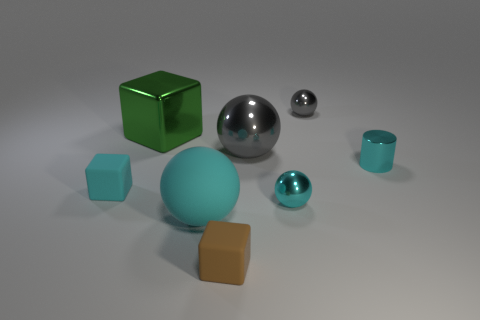What is the color of the tiny cylinder?
Provide a succinct answer. Cyan. There is a small shiny ball that is behind the cyan block; is there a thing in front of it?
Your answer should be compact. Yes. Is the number of small gray shiny objects that are in front of the big gray shiny ball less than the number of green metal cubes?
Provide a short and direct response. Yes. Are the tiny block that is to the right of the green object and the big green object made of the same material?
Your answer should be compact. No. What color is the small cylinder that is the same material as the big green object?
Offer a terse response. Cyan. Is the number of cyan metallic spheres that are behind the green object less than the number of rubber things that are behind the brown matte object?
Provide a short and direct response. Yes. Does the tiny shiny ball in front of the cyan metal cylinder have the same color as the tiny thing that is in front of the tiny cyan ball?
Keep it short and to the point. No. Is there another cube that has the same material as the tiny cyan block?
Give a very brief answer. Yes. What size is the cyan shiny object in front of the rubber block that is left of the large green shiny object?
Provide a short and direct response. Small. Are there more big metallic things than large green matte blocks?
Your answer should be compact. Yes. 